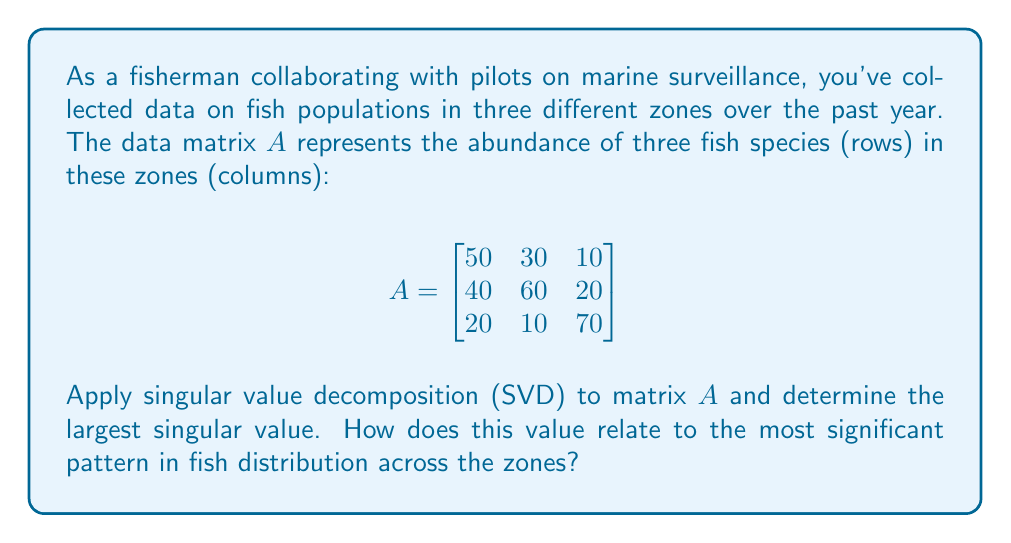Can you solve this math problem? To solve this problem, we'll follow these steps:

1) The singular value decomposition of matrix $A$ is given by $A = U\Sigma V^T$, where $U$ and $V$ are orthogonal matrices and $\Sigma$ is a diagonal matrix containing the singular values.

2) To find the singular values, we first calculate $A^TA$:

   $$A^TA = \begin{bmatrix}
   50 & 40 & 20 \\
   30 & 60 & 10 \\
   10 & 20 & 70
   \end{bmatrix} \begin{bmatrix}
   50 & 30 & 10 \\
   40 & 60 & 20 \\
   20 & 10 & 70
   \end{bmatrix} = \begin{bmatrix}
   4600 & 5100 & 2900 \\
   5100 & 5800 & 3100 \\
   2900 & 3100 & 5300
   \end{bmatrix}$$

3) The eigenvalues of $A^TA$ are the squares of the singular values of $A$. We can find these using a characteristic equation or a numerical method. The eigenvalues are approximately:

   $\lambda_1 \approx 13829.7$
   $\lambda_2 \approx 1486.3$
   $\lambda_3 \approx 384.0$

4) The singular values are the square roots of these eigenvalues:

   $\sigma_1 \approx \sqrt{13829.7} \approx 117.6$
   $\sigma_2 \approx \sqrt{1486.3} \approx 38.6$
   $\sigma_3 \approx \sqrt{384.0} \approx 19.6$

5) The largest singular value is $\sigma_1 \approx 117.6$.

6) In the context of fish distribution, the largest singular value corresponds to the most significant pattern in the data. It represents the direction of maximum variance in the dataset, indicating the dominant trend in fish abundance across the three zones.

7) A larger singular value suggests a stronger, more defined pattern. In this case, the first singular value being significantly larger than the others indicates that there's a dominant distribution pattern across the zones that explains most of the variation in the data.
Answer: $117.6$, representing the dominant fish distribution pattern across zones. 